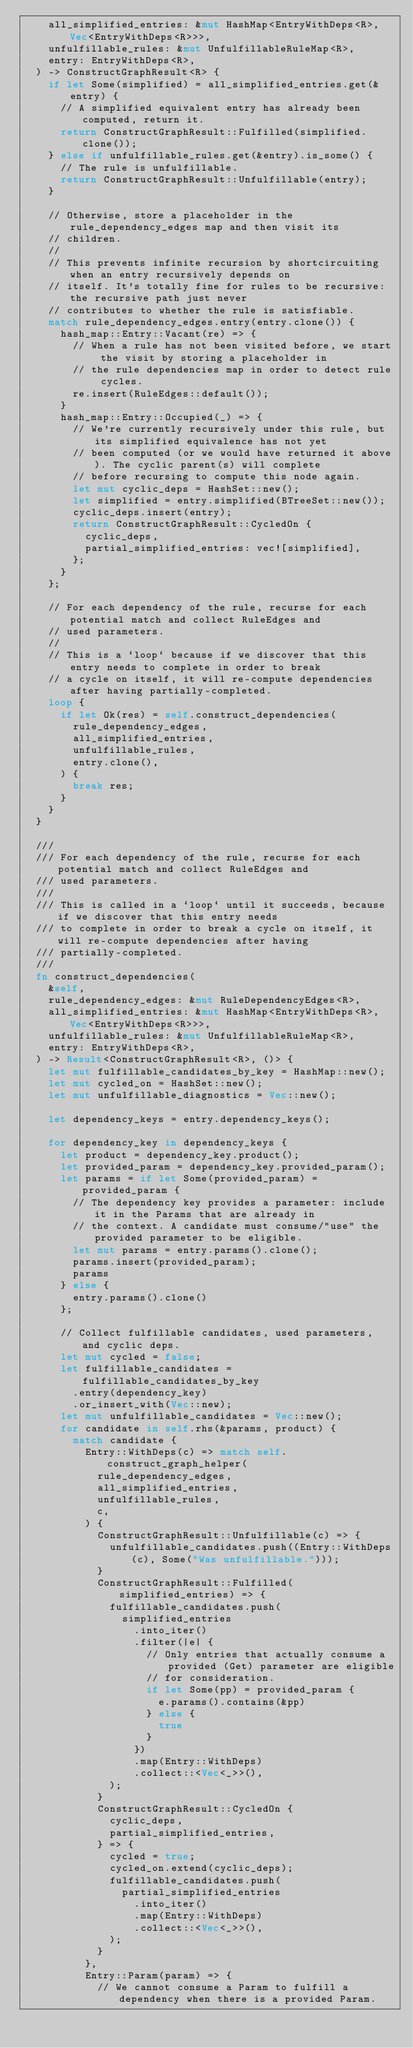Convert code to text. <code><loc_0><loc_0><loc_500><loc_500><_Rust_>    all_simplified_entries: &mut HashMap<EntryWithDeps<R>, Vec<EntryWithDeps<R>>>,
    unfulfillable_rules: &mut UnfulfillableRuleMap<R>,
    entry: EntryWithDeps<R>,
  ) -> ConstructGraphResult<R> {
    if let Some(simplified) = all_simplified_entries.get(&entry) {
      // A simplified equivalent entry has already been computed, return it.
      return ConstructGraphResult::Fulfilled(simplified.clone());
    } else if unfulfillable_rules.get(&entry).is_some() {
      // The rule is unfulfillable.
      return ConstructGraphResult::Unfulfillable(entry);
    }

    // Otherwise, store a placeholder in the rule_dependency_edges map and then visit its
    // children.
    //
    // This prevents infinite recursion by shortcircuiting when an entry recursively depends on
    // itself. It's totally fine for rules to be recursive: the recursive path just never
    // contributes to whether the rule is satisfiable.
    match rule_dependency_edges.entry(entry.clone()) {
      hash_map::Entry::Vacant(re) => {
        // When a rule has not been visited before, we start the visit by storing a placeholder in
        // the rule dependencies map in order to detect rule cycles.
        re.insert(RuleEdges::default());
      }
      hash_map::Entry::Occupied(_) => {
        // We're currently recursively under this rule, but its simplified equivalence has not yet
        // been computed (or we would have returned it above). The cyclic parent(s) will complete
        // before recursing to compute this node again.
        let mut cyclic_deps = HashSet::new();
        let simplified = entry.simplified(BTreeSet::new());
        cyclic_deps.insert(entry);
        return ConstructGraphResult::CycledOn {
          cyclic_deps,
          partial_simplified_entries: vec![simplified],
        };
      }
    };

    // For each dependency of the rule, recurse for each potential match and collect RuleEdges and
    // used parameters.
    //
    // This is a `loop` because if we discover that this entry needs to complete in order to break
    // a cycle on itself, it will re-compute dependencies after having partially-completed.
    loop {
      if let Ok(res) = self.construct_dependencies(
        rule_dependency_edges,
        all_simplified_entries,
        unfulfillable_rules,
        entry.clone(),
      ) {
        break res;
      }
    }
  }

  ///
  /// For each dependency of the rule, recurse for each potential match and collect RuleEdges and
  /// used parameters.
  ///
  /// This is called in a `loop` until it succeeds, because if we discover that this entry needs
  /// to complete in order to break a cycle on itself, it will re-compute dependencies after having
  /// partially-completed.
  ///
  fn construct_dependencies(
    &self,
    rule_dependency_edges: &mut RuleDependencyEdges<R>,
    all_simplified_entries: &mut HashMap<EntryWithDeps<R>, Vec<EntryWithDeps<R>>>,
    unfulfillable_rules: &mut UnfulfillableRuleMap<R>,
    entry: EntryWithDeps<R>,
  ) -> Result<ConstructGraphResult<R>, ()> {
    let mut fulfillable_candidates_by_key = HashMap::new();
    let mut cycled_on = HashSet::new();
    let mut unfulfillable_diagnostics = Vec::new();

    let dependency_keys = entry.dependency_keys();

    for dependency_key in dependency_keys {
      let product = dependency_key.product();
      let provided_param = dependency_key.provided_param();
      let params = if let Some(provided_param) = provided_param {
        // The dependency key provides a parameter: include it in the Params that are already in
        // the context. A candidate must consume/"use" the provided parameter to be eligible.
        let mut params = entry.params().clone();
        params.insert(provided_param);
        params
      } else {
        entry.params().clone()
      };

      // Collect fulfillable candidates, used parameters, and cyclic deps.
      let mut cycled = false;
      let fulfillable_candidates = fulfillable_candidates_by_key
        .entry(dependency_key)
        .or_insert_with(Vec::new);
      let mut unfulfillable_candidates = Vec::new();
      for candidate in self.rhs(&params, product) {
        match candidate {
          Entry::WithDeps(c) => match self.construct_graph_helper(
            rule_dependency_edges,
            all_simplified_entries,
            unfulfillable_rules,
            c,
          ) {
            ConstructGraphResult::Unfulfillable(c) => {
              unfulfillable_candidates.push((Entry::WithDeps(c), Some("Was unfulfillable.")));
            }
            ConstructGraphResult::Fulfilled(simplified_entries) => {
              fulfillable_candidates.push(
                simplified_entries
                  .into_iter()
                  .filter(|e| {
                    // Only entries that actually consume a provided (Get) parameter are eligible
                    // for consideration.
                    if let Some(pp) = provided_param {
                      e.params().contains(&pp)
                    } else {
                      true
                    }
                  })
                  .map(Entry::WithDeps)
                  .collect::<Vec<_>>(),
              );
            }
            ConstructGraphResult::CycledOn {
              cyclic_deps,
              partial_simplified_entries,
            } => {
              cycled = true;
              cycled_on.extend(cyclic_deps);
              fulfillable_candidates.push(
                partial_simplified_entries
                  .into_iter()
                  .map(Entry::WithDeps)
                  .collect::<Vec<_>>(),
              );
            }
          },
          Entry::Param(param) => {
            // We cannot consume a Param to fulfill a dependency when there is a provided Param.</code> 